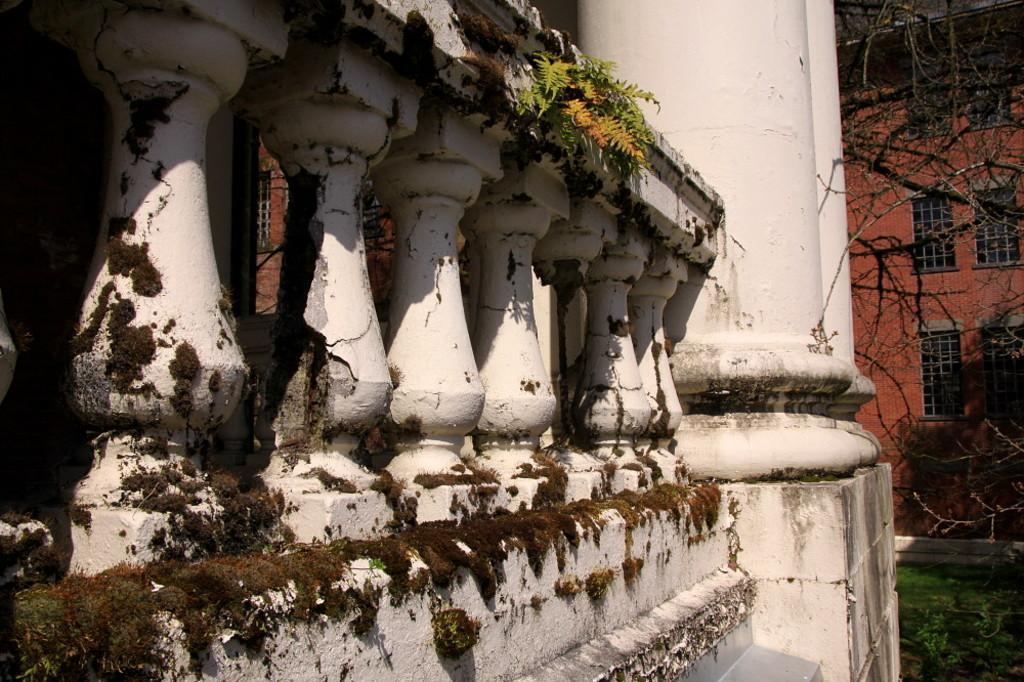In one or two sentences, can you explain what this image depicts? This picture is clicked outside. On the left we can see the leaves and a guard rail and we can see the pillars. On the right we can see the green grass, dry stems and a building and we can see the windows of the building. 